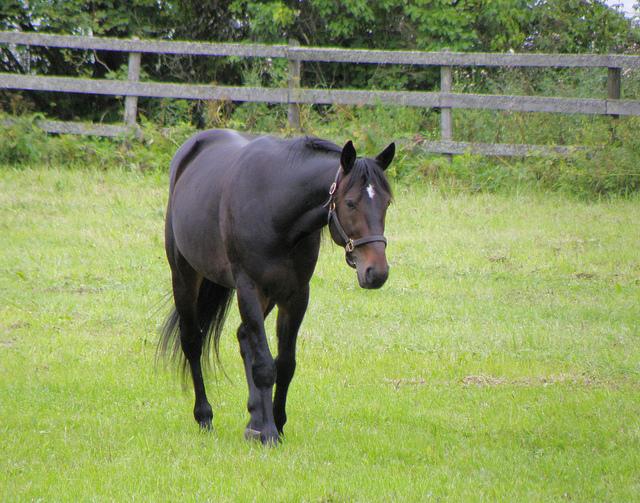Where is the white spot on the horse?
Quick response, please. Head. Is the horse walking backwards?
Be succinct. No. Is there a saddle on the horse?
Give a very brief answer. No. 